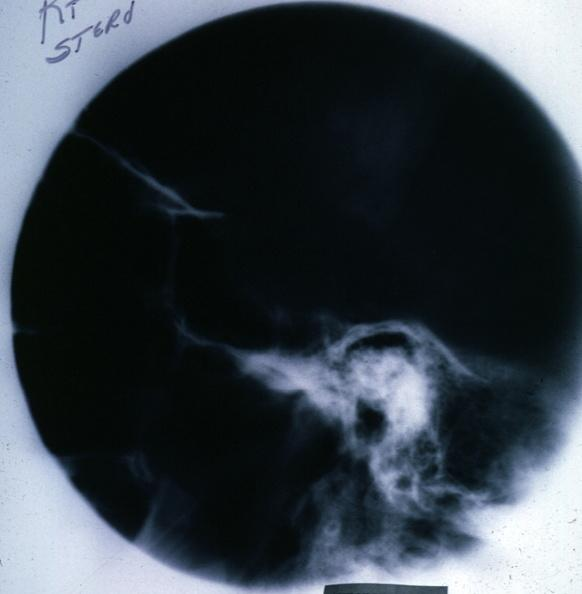s pituitary present?
Answer the question using a single word or phrase. Yes 